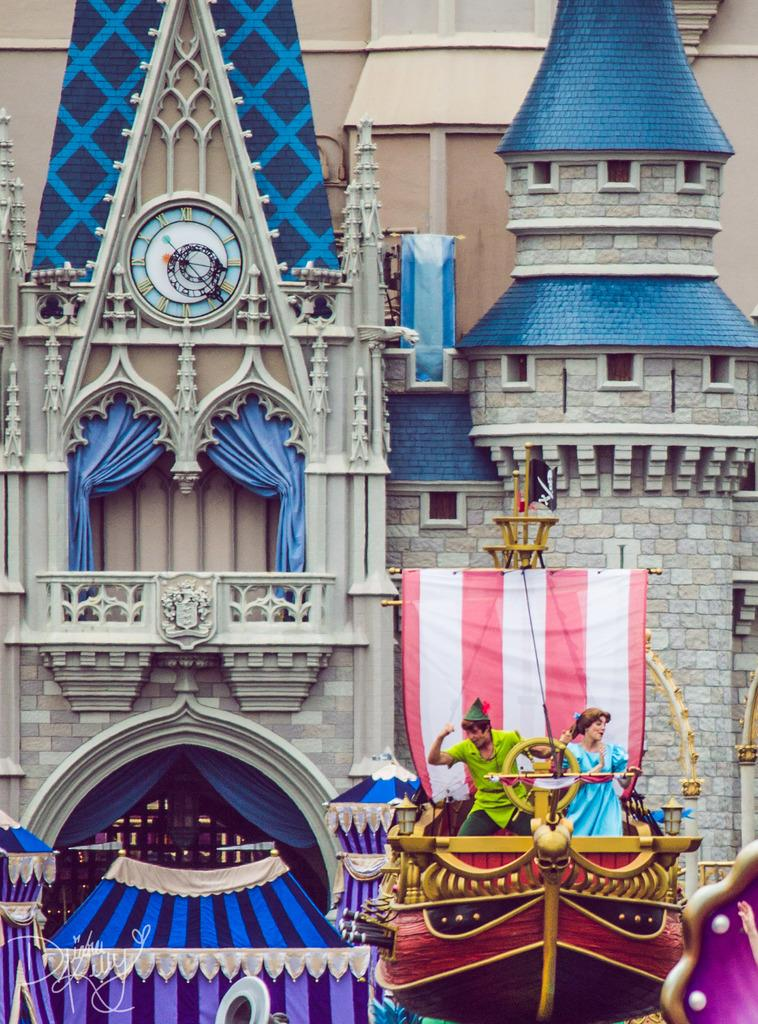What type of structure is located on the right side of the image? There is a boat-like structure on the right side of the image. What are the people on the boat-like structure doing? People are dancing on the boat-like structure. What can be seen in the image besides the boat-like structure and people? There is a flag in the image. What is visible in the background of the image? There is a building with a clock in the background, and curtains are present in the building. What color is the pencil used by the parent in the image? There is no pencil or parent present in the image. How does the hair of the person dancing on the boat-like structure look? The image does not provide information about the hairstyle of the people dancing on the boat-like structure. 